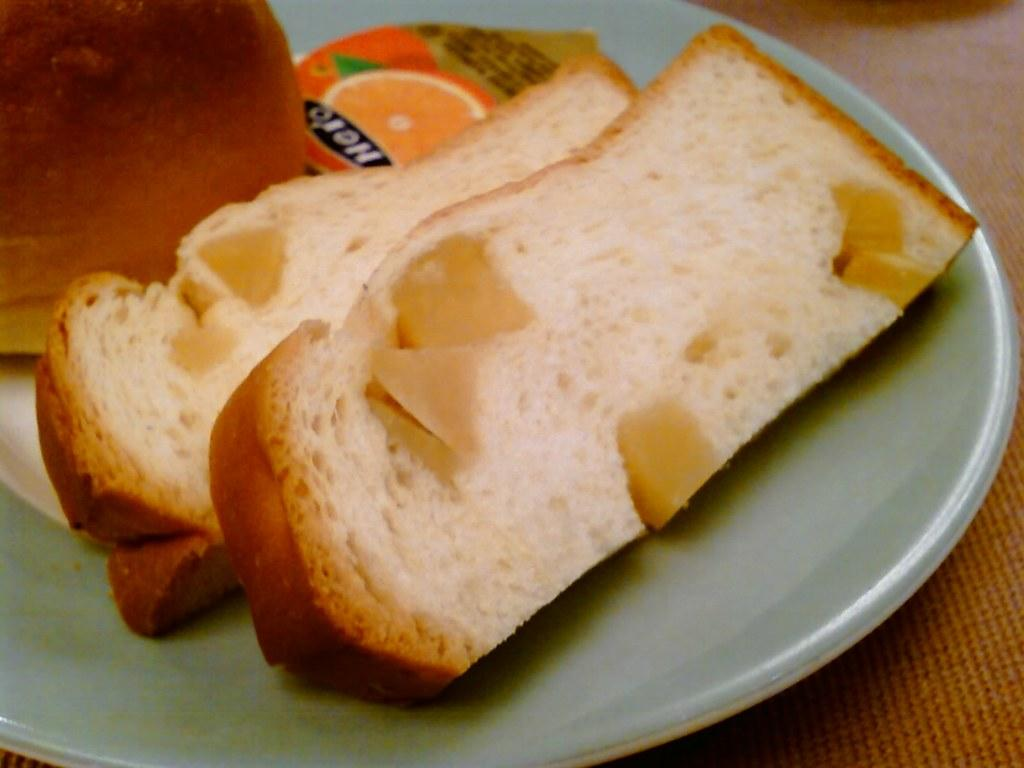What type of food can be seen in the image? There are bread slices in the image. How are the bread slices arranged or presented? The bread slices are in a plate. What type of bike is visible in the image? There is no bike present in the image; it only features bread slices in a plate. 